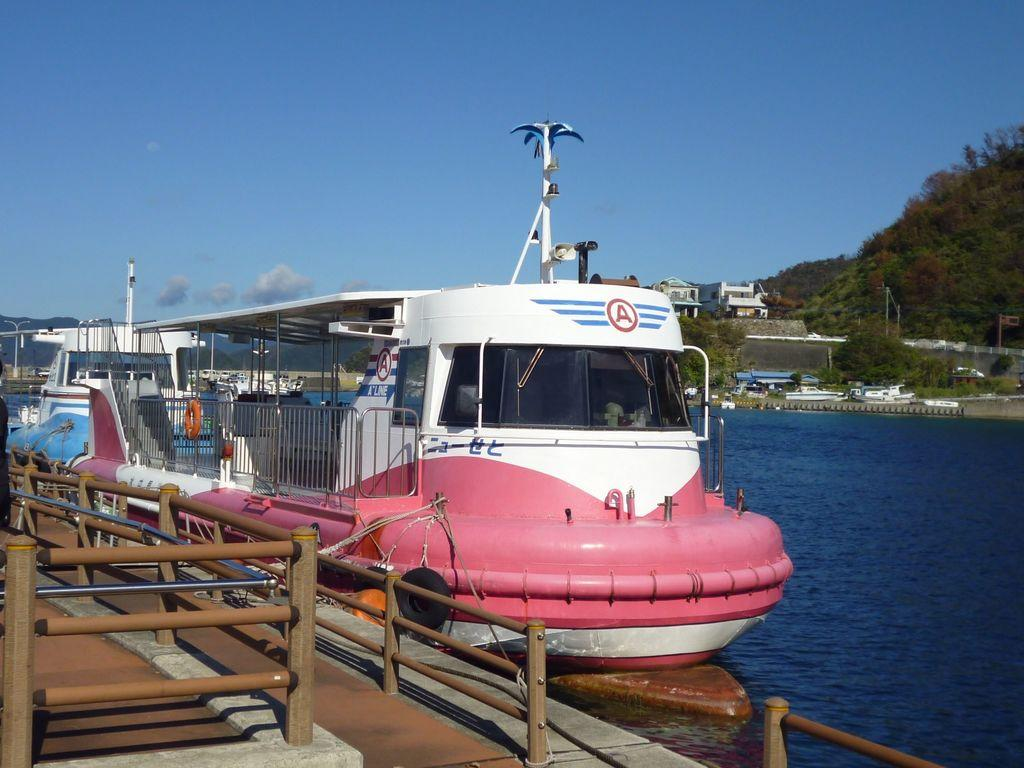What type of vehicles are in the image? There are boats in the image. What is the primary element in which the boats are situated? There is water visible in the image. What type of pathway can be seen in the image? There is a walkway in the image. What are the long, thin objects in the image? There are rods in the image. What type of vegetation is visible in the background of the image? The background of the image includes trees. What type of structures are visible in the background of the image? There are poles and houses in the background of the image. What part of the natural environment is visible in the background of the image? The sky is visible in the background of the image. Where is the cave located in the image? There is no cave present in the image. 